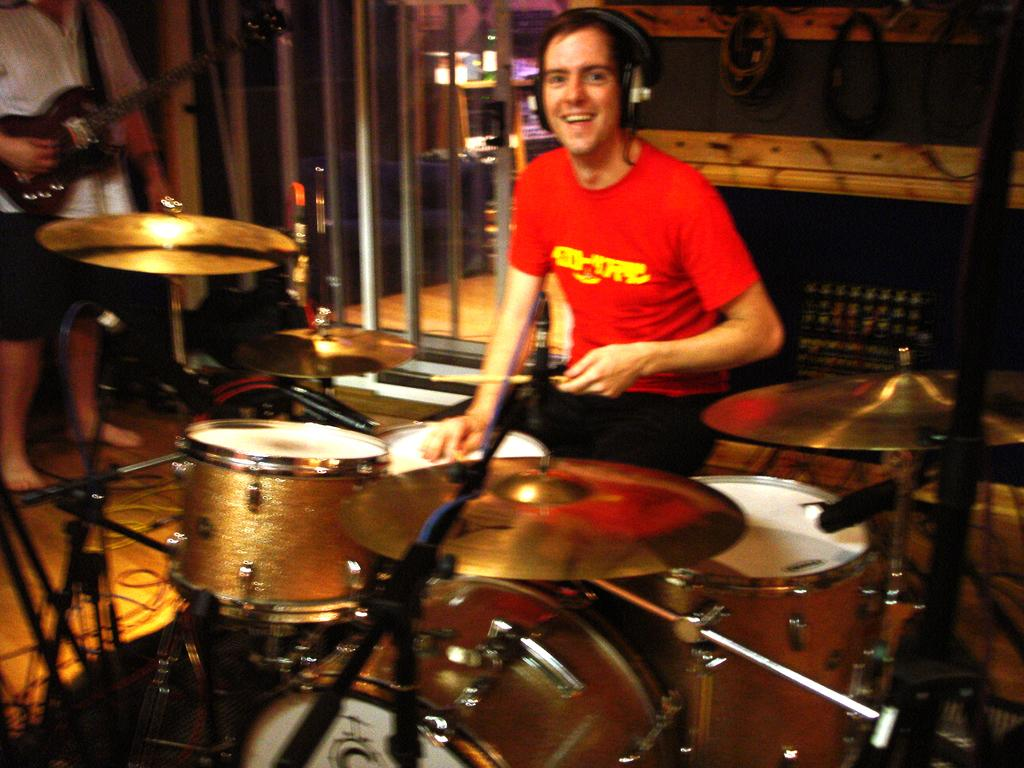What is the main activity taking place in the image? There is a person playing drums in the center of the image. What other musical instrument can be seen in the image? There is a person playing guitar on the left side of the image. What can be seen in the background of the image? There is a room in the background of the image. What else is present in the room besides the people playing instruments? There are objects present in the room. What type of weather can be seen through the window in the image? There is no window or weather mentioned in the image; it focuses on the people playing musical instruments and the room they are in. 